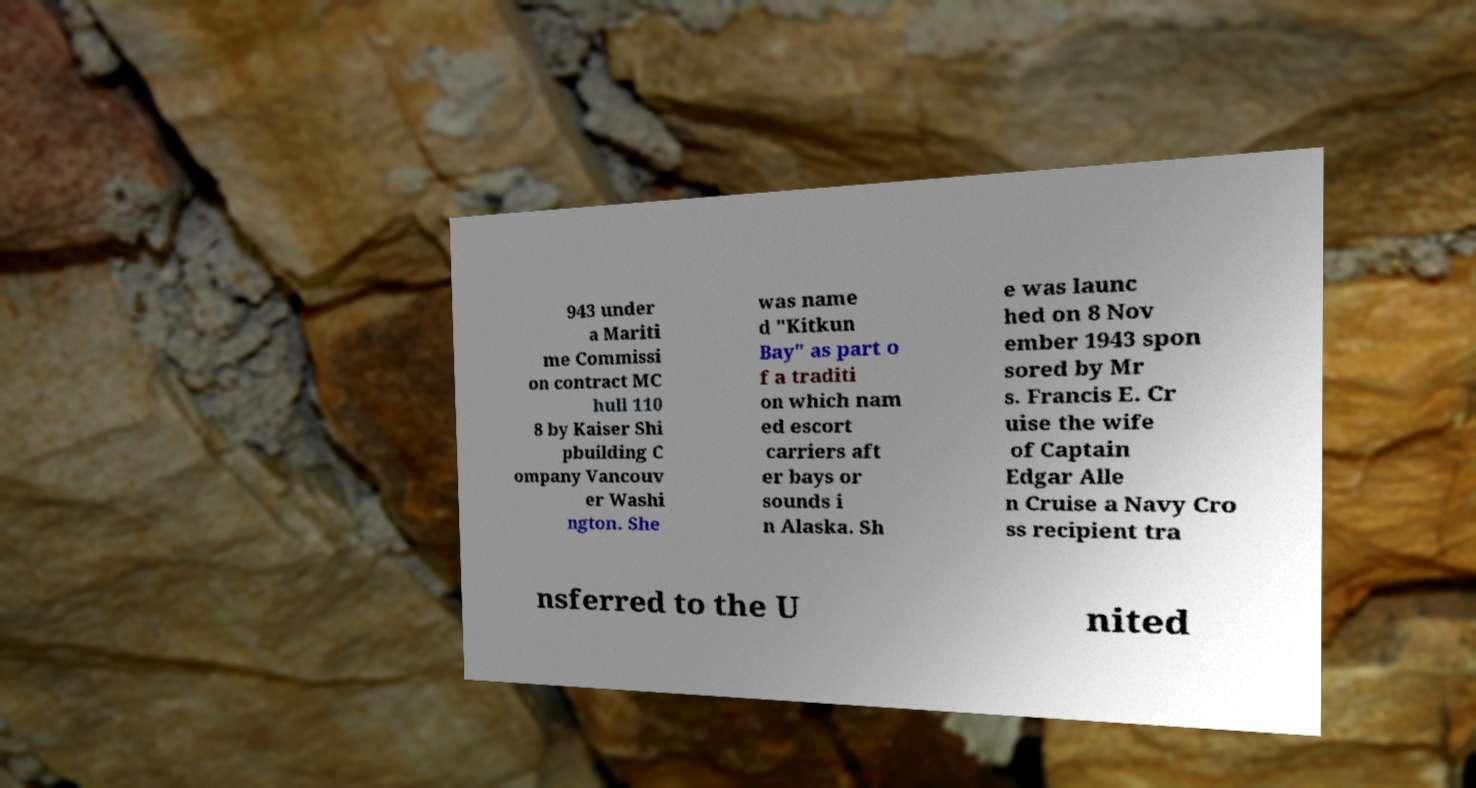What messages or text are displayed in this image? I need them in a readable, typed format. 943 under a Mariti me Commissi on contract MC hull 110 8 by Kaiser Shi pbuilding C ompany Vancouv er Washi ngton. She was name d "Kitkun Bay" as part o f a traditi on which nam ed escort carriers aft er bays or sounds i n Alaska. Sh e was launc hed on 8 Nov ember 1943 spon sored by Mr s. Francis E. Cr uise the wife of Captain Edgar Alle n Cruise a Navy Cro ss recipient tra nsferred to the U nited 